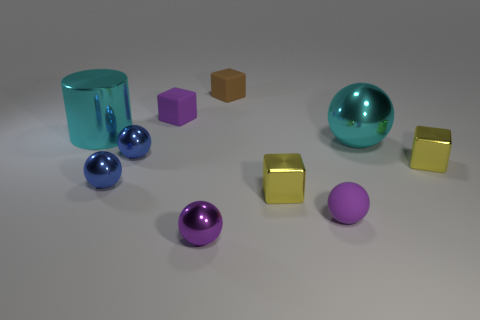Is the number of large yellow metallic cubes less than the number of purple matte spheres? Yes, the number of large yellow metallic cubes, which is two, is indeed less than the number of purple matte spheres present, totaling three. 